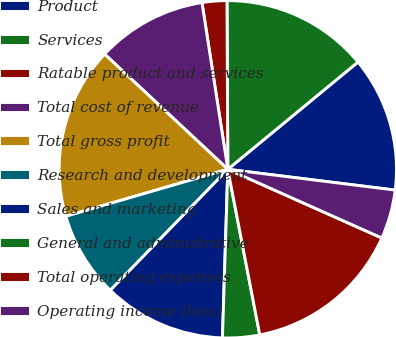<chart> <loc_0><loc_0><loc_500><loc_500><pie_chart><fcel>Product<fcel>Services<fcel>Ratable product and services<fcel>Total cost of revenue<fcel>Total gross profit<fcel>Research and development<fcel>Sales and marketing<fcel>General and administrative<fcel>Total operating expenses<fcel>Operating income (loss)<nl><fcel>12.94%<fcel>14.11%<fcel>2.37%<fcel>10.59%<fcel>16.46%<fcel>8.24%<fcel>11.76%<fcel>3.54%<fcel>15.29%<fcel>4.71%<nl></chart> 